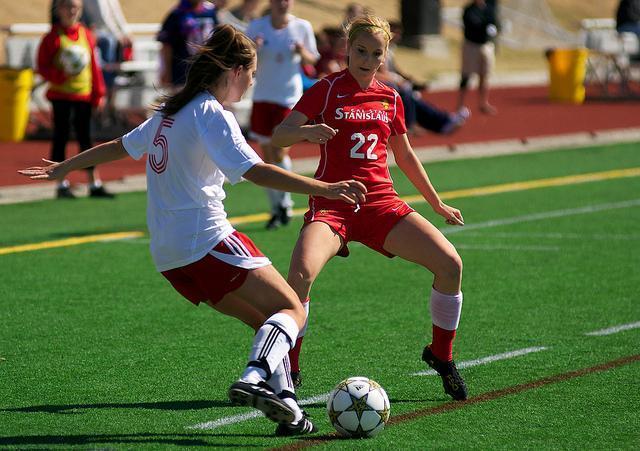How many people are there?
Give a very brief answer. 7. How many black umbrellas are there?
Give a very brief answer. 0. 